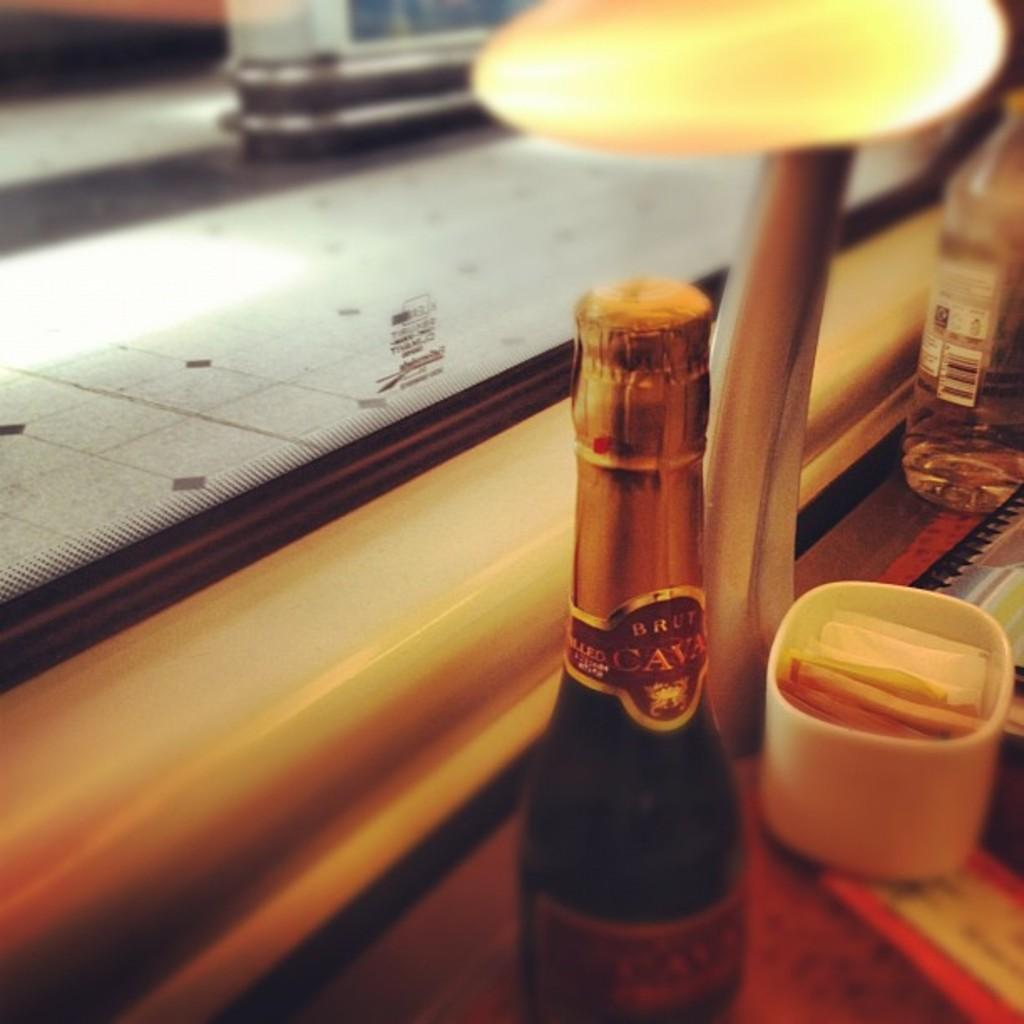<image>
Provide a brief description of the given image. the word cava is on a bottle that is green 